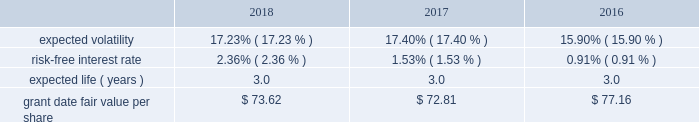Condition are valued using a monte carlo model .
Expected volatility is based on historical volatilities of traded common stock of the company and comparative companies using daily stock prices over the past three years .
The expected term is three years and the risk-free interest rate is based on the three-year u.s .
Treasury rate in effect as of the measurement date .
The table provides the weighted average assumptions used in the monte carlo simulation and the weighted average grant date fair values of psus granted for the years ended december 31: .
The grant date fair value of psus that vest ratably and have market and/or performance conditions are amortized through expense over the requisite service period using the graded-vesting method .
If dividends are paid with respect to shares of the company 2019s common stock before the rsus and psus are distributed , the company credits a liability for the value of the dividends that would have been paid if the rsus and psus were shares of company common stock .
When the rsus and psus are distributed , the company pays the participant a lump sum cash payment equal to the value of the dividend equivalents accrued .
The company accrued dividend equivalents totaling $ 1 million , less than $ 1 million and $ 1 million to accumulated deficit in the accompanying consolidated statements of changes in shareholders 2019 equity for the years ended december 31 , 2018 , 2017 and 2016 , respectively .
Employee stock purchase plan the company maintains a nonqualified employee stock purchase plan ( the 201cespp 201d ) through which employee participants may use payroll deductions to acquire company common stock at a discount .
Prior to february 5 , 2019 , the purchase price of common stock acquired under the espp was the lesser of 90% ( 90 % ) of the fair market value of the common stock at either the beginning or the end of a three -month purchase period .
On july 27 , 2018 , the espp was amended , effective february 5 , 2019 , to permit employee participants to acquire company common stock at 85% ( 85 % ) of the fair market value of the common stock at the end of the purchase period .
As of december 31 , 2018 , there were 1.9 million shares of common stock reserved for issuance under the espp .
The espp is considered compensatory .
During the years ended december 31 , 2018 , 2017 and 2016 , the company issued 95 thousand , 93 thousand and 93 thousand shares , respectively , under the espp. .
By how much did the grant date fair value per share increase from 2017 to 2018? 
Computations: ((73.62 - 72.81) / 72.81)
Answer: 0.01112. 